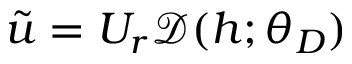<formula> <loc_0><loc_0><loc_500><loc_500>\tilde { u } = U _ { r } \mathcal { D } ( h ; \theta _ { D } )</formula> 